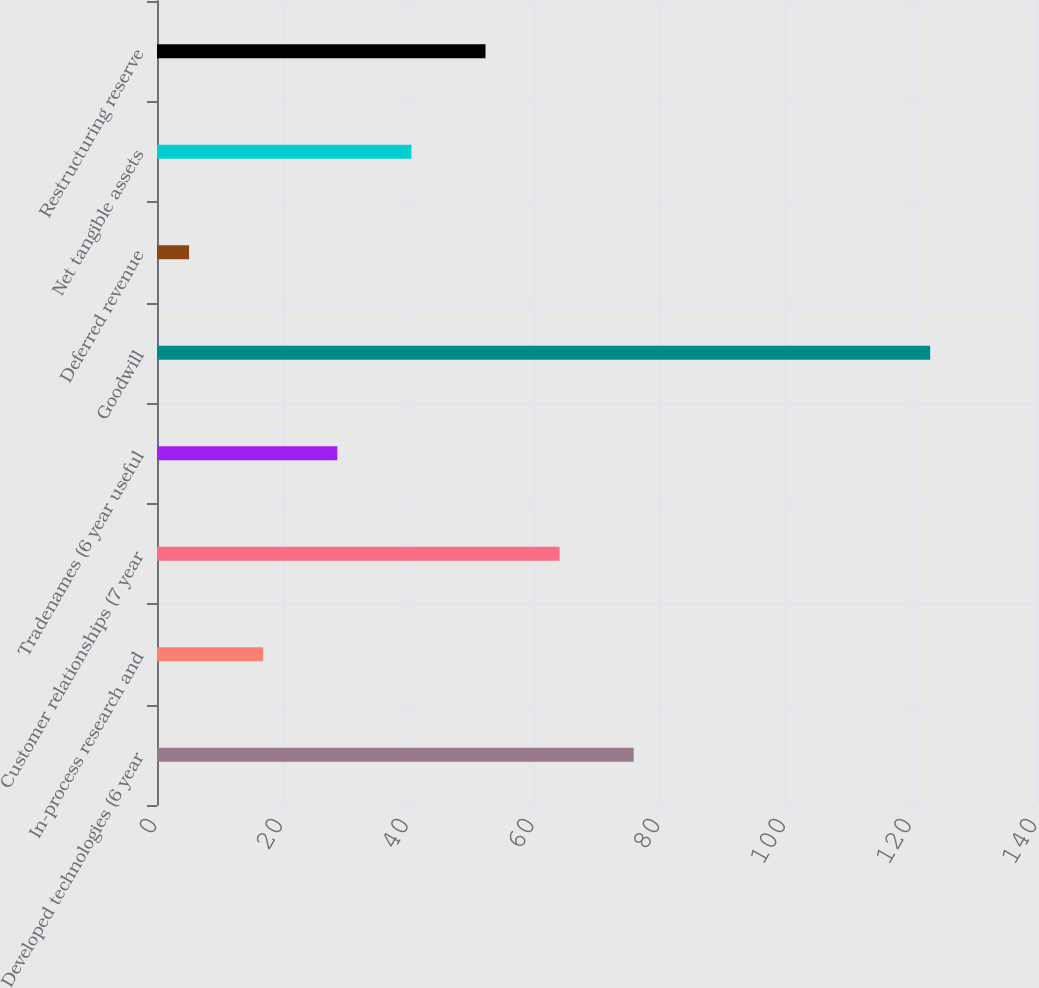Convert chart to OTSL. <chart><loc_0><loc_0><loc_500><loc_500><bar_chart><fcel>Developed technologies (6 year<fcel>In-process research and<fcel>Customer relationships (7 year<fcel>Tradenames (6 year useful<fcel>Goodwill<fcel>Deferred revenue<fcel>Net tangible assets<fcel>Restructuring reserve<nl><fcel>75.84<fcel>16.89<fcel>64.05<fcel>28.68<fcel>123<fcel>5.1<fcel>40.47<fcel>52.26<nl></chart> 